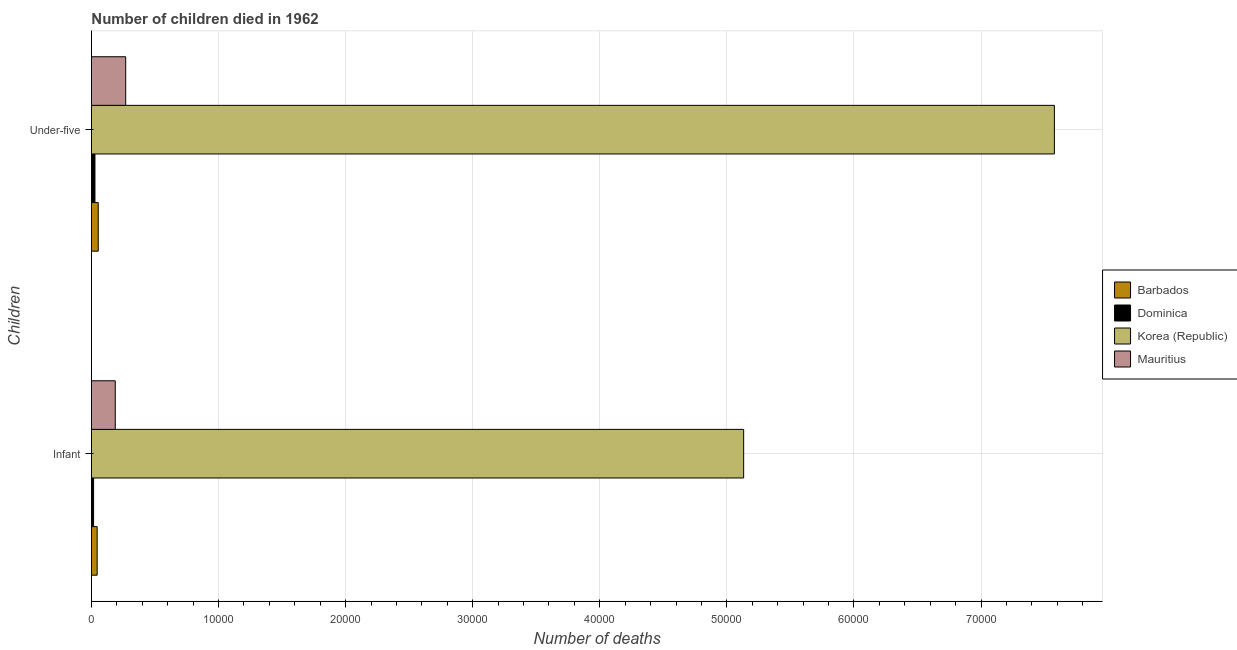How many bars are there on the 1st tick from the bottom?
Ensure brevity in your answer.  4. What is the label of the 1st group of bars from the top?
Keep it short and to the point. Under-five. What is the number of infant deaths in Barbados?
Your response must be concise. 451. Across all countries, what is the maximum number of infant deaths?
Provide a succinct answer. 5.13e+04. Across all countries, what is the minimum number of under-five deaths?
Offer a terse response. 278. In which country was the number of infant deaths minimum?
Ensure brevity in your answer.  Dominica. What is the total number of infant deaths in the graph?
Provide a short and direct response. 5.38e+04. What is the difference between the number of under-five deaths in Mauritius and that in Korea (Republic)?
Ensure brevity in your answer.  -7.31e+04. What is the difference between the number of infant deaths in Dominica and the number of under-five deaths in Barbados?
Provide a short and direct response. -365. What is the average number of under-five deaths per country?
Provide a succinct answer. 1.98e+04. What is the difference between the number of under-five deaths and number of infant deaths in Korea (Republic)?
Provide a short and direct response. 2.44e+04. In how many countries, is the number of infant deaths greater than 24000 ?
Offer a terse response. 1. What is the ratio of the number of infant deaths in Mauritius to that in Korea (Republic)?
Your response must be concise. 0.04. What does the 1st bar from the top in Infant represents?
Make the answer very short. Mauritius. What does the 2nd bar from the bottom in Under-five represents?
Give a very brief answer. Dominica. Are all the bars in the graph horizontal?
Offer a terse response. Yes. How many countries are there in the graph?
Provide a succinct answer. 4. Does the graph contain any zero values?
Your response must be concise. No. Where does the legend appear in the graph?
Your response must be concise. Center right. How many legend labels are there?
Keep it short and to the point. 4. How are the legend labels stacked?
Your answer should be compact. Vertical. What is the title of the graph?
Provide a short and direct response. Number of children died in 1962. What is the label or title of the X-axis?
Your answer should be very brief. Number of deaths. What is the label or title of the Y-axis?
Ensure brevity in your answer.  Children. What is the Number of deaths of Barbados in Infant?
Keep it short and to the point. 451. What is the Number of deaths of Dominica in Infant?
Provide a succinct answer. 171. What is the Number of deaths in Korea (Republic) in Infant?
Give a very brief answer. 5.13e+04. What is the Number of deaths in Mauritius in Infant?
Ensure brevity in your answer.  1876. What is the Number of deaths of Barbados in Under-five?
Your answer should be compact. 536. What is the Number of deaths of Dominica in Under-five?
Keep it short and to the point. 278. What is the Number of deaths of Korea (Republic) in Under-five?
Provide a short and direct response. 7.58e+04. What is the Number of deaths in Mauritius in Under-five?
Your response must be concise. 2697. Across all Children, what is the maximum Number of deaths of Barbados?
Offer a terse response. 536. Across all Children, what is the maximum Number of deaths of Dominica?
Ensure brevity in your answer.  278. Across all Children, what is the maximum Number of deaths of Korea (Republic)?
Keep it short and to the point. 7.58e+04. Across all Children, what is the maximum Number of deaths in Mauritius?
Your answer should be very brief. 2697. Across all Children, what is the minimum Number of deaths in Barbados?
Keep it short and to the point. 451. Across all Children, what is the minimum Number of deaths in Dominica?
Your response must be concise. 171. Across all Children, what is the minimum Number of deaths in Korea (Republic)?
Offer a terse response. 5.13e+04. Across all Children, what is the minimum Number of deaths in Mauritius?
Your response must be concise. 1876. What is the total Number of deaths in Barbados in the graph?
Provide a short and direct response. 987. What is the total Number of deaths of Dominica in the graph?
Keep it short and to the point. 449. What is the total Number of deaths in Korea (Republic) in the graph?
Offer a terse response. 1.27e+05. What is the total Number of deaths of Mauritius in the graph?
Provide a succinct answer. 4573. What is the difference between the Number of deaths of Barbados in Infant and that in Under-five?
Your response must be concise. -85. What is the difference between the Number of deaths in Dominica in Infant and that in Under-five?
Ensure brevity in your answer.  -107. What is the difference between the Number of deaths in Korea (Republic) in Infant and that in Under-five?
Keep it short and to the point. -2.44e+04. What is the difference between the Number of deaths in Mauritius in Infant and that in Under-five?
Your response must be concise. -821. What is the difference between the Number of deaths in Barbados in Infant and the Number of deaths in Dominica in Under-five?
Provide a succinct answer. 173. What is the difference between the Number of deaths of Barbados in Infant and the Number of deaths of Korea (Republic) in Under-five?
Provide a short and direct response. -7.53e+04. What is the difference between the Number of deaths of Barbados in Infant and the Number of deaths of Mauritius in Under-five?
Keep it short and to the point. -2246. What is the difference between the Number of deaths in Dominica in Infant and the Number of deaths in Korea (Republic) in Under-five?
Your response must be concise. -7.56e+04. What is the difference between the Number of deaths in Dominica in Infant and the Number of deaths in Mauritius in Under-five?
Your answer should be compact. -2526. What is the difference between the Number of deaths in Korea (Republic) in Infant and the Number of deaths in Mauritius in Under-five?
Your answer should be compact. 4.86e+04. What is the average Number of deaths of Barbados per Children?
Provide a short and direct response. 493.5. What is the average Number of deaths of Dominica per Children?
Keep it short and to the point. 224.5. What is the average Number of deaths in Korea (Republic) per Children?
Ensure brevity in your answer.  6.35e+04. What is the average Number of deaths of Mauritius per Children?
Your answer should be very brief. 2286.5. What is the difference between the Number of deaths of Barbados and Number of deaths of Dominica in Infant?
Provide a short and direct response. 280. What is the difference between the Number of deaths of Barbados and Number of deaths of Korea (Republic) in Infant?
Offer a very short reply. -5.09e+04. What is the difference between the Number of deaths of Barbados and Number of deaths of Mauritius in Infant?
Keep it short and to the point. -1425. What is the difference between the Number of deaths of Dominica and Number of deaths of Korea (Republic) in Infant?
Keep it short and to the point. -5.11e+04. What is the difference between the Number of deaths of Dominica and Number of deaths of Mauritius in Infant?
Make the answer very short. -1705. What is the difference between the Number of deaths of Korea (Republic) and Number of deaths of Mauritius in Infant?
Provide a succinct answer. 4.94e+04. What is the difference between the Number of deaths in Barbados and Number of deaths in Dominica in Under-five?
Your response must be concise. 258. What is the difference between the Number of deaths in Barbados and Number of deaths in Korea (Republic) in Under-five?
Give a very brief answer. -7.52e+04. What is the difference between the Number of deaths in Barbados and Number of deaths in Mauritius in Under-five?
Provide a short and direct response. -2161. What is the difference between the Number of deaths of Dominica and Number of deaths of Korea (Republic) in Under-five?
Provide a short and direct response. -7.55e+04. What is the difference between the Number of deaths in Dominica and Number of deaths in Mauritius in Under-five?
Your answer should be very brief. -2419. What is the difference between the Number of deaths of Korea (Republic) and Number of deaths of Mauritius in Under-five?
Provide a short and direct response. 7.31e+04. What is the ratio of the Number of deaths of Barbados in Infant to that in Under-five?
Your response must be concise. 0.84. What is the ratio of the Number of deaths in Dominica in Infant to that in Under-five?
Provide a short and direct response. 0.62. What is the ratio of the Number of deaths in Korea (Republic) in Infant to that in Under-five?
Offer a terse response. 0.68. What is the ratio of the Number of deaths in Mauritius in Infant to that in Under-five?
Your answer should be compact. 0.7. What is the difference between the highest and the second highest Number of deaths in Barbados?
Provide a short and direct response. 85. What is the difference between the highest and the second highest Number of deaths of Dominica?
Provide a succinct answer. 107. What is the difference between the highest and the second highest Number of deaths of Korea (Republic)?
Offer a terse response. 2.44e+04. What is the difference between the highest and the second highest Number of deaths in Mauritius?
Offer a terse response. 821. What is the difference between the highest and the lowest Number of deaths in Dominica?
Your response must be concise. 107. What is the difference between the highest and the lowest Number of deaths of Korea (Republic)?
Keep it short and to the point. 2.44e+04. What is the difference between the highest and the lowest Number of deaths in Mauritius?
Offer a very short reply. 821. 